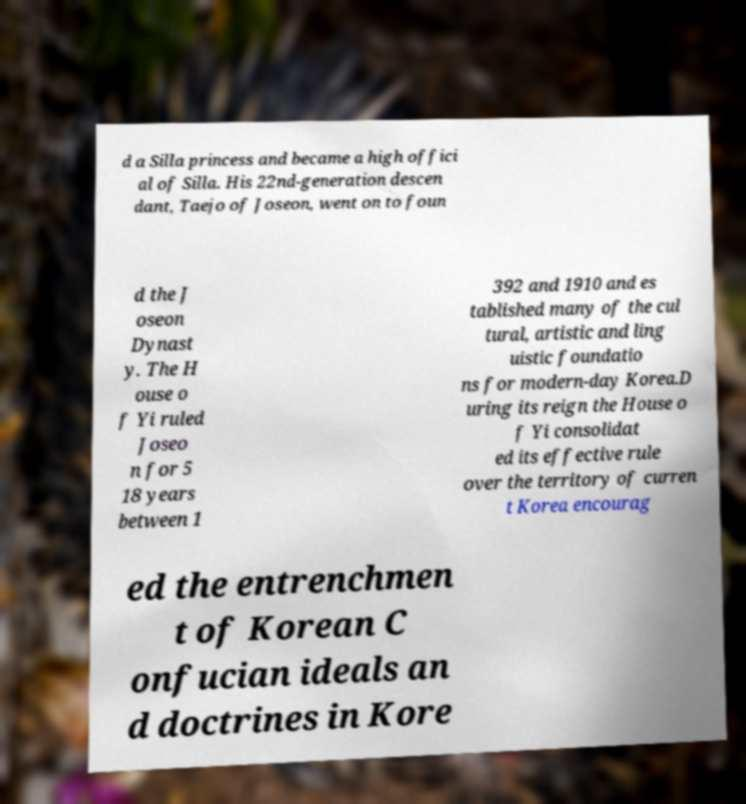What messages or text are displayed in this image? I need them in a readable, typed format. d a Silla princess and became a high offici al of Silla. His 22nd-generation descen dant, Taejo of Joseon, went on to foun d the J oseon Dynast y. The H ouse o f Yi ruled Joseo n for 5 18 years between 1 392 and 1910 and es tablished many of the cul tural, artistic and ling uistic foundatio ns for modern-day Korea.D uring its reign the House o f Yi consolidat ed its effective rule over the territory of curren t Korea encourag ed the entrenchmen t of Korean C onfucian ideals an d doctrines in Kore 